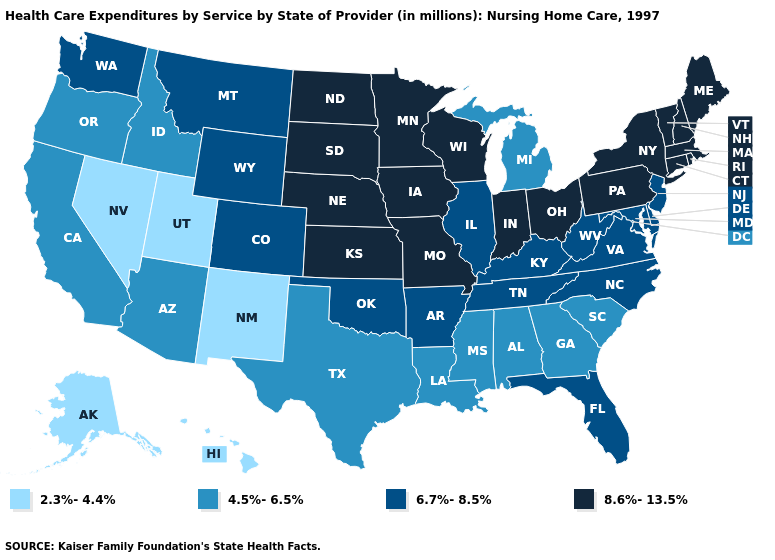Among the states that border New York , which have the lowest value?
Write a very short answer. New Jersey. Does Louisiana have a higher value than Nevada?
Quick response, please. Yes. What is the highest value in the USA?
Give a very brief answer. 8.6%-13.5%. Among the states that border Texas , does Arkansas have the highest value?
Concise answer only. Yes. What is the highest value in the USA?
Quick response, please. 8.6%-13.5%. What is the lowest value in states that border New York?
Write a very short answer. 6.7%-8.5%. How many symbols are there in the legend?
Write a very short answer. 4. Does Massachusetts have the lowest value in the USA?
Be succinct. No. How many symbols are there in the legend?
Give a very brief answer. 4. Name the states that have a value in the range 2.3%-4.4%?
Answer briefly. Alaska, Hawaii, Nevada, New Mexico, Utah. What is the value of Wisconsin?
Keep it brief. 8.6%-13.5%. Does the first symbol in the legend represent the smallest category?
Quick response, please. Yes. Name the states that have a value in the range 6.7%-8.5%?
Be succinct. Arkansas, Colorado, Delaware, Florida, Illinois, Kentucky, Maryland, Montana, New Jersey, North Carolina, Oklahoma, Tennessee, Virginia, Washington, West Virginia, Wyoming. Among the states that border New York , which have the highest value?
Answer briefly. Connecticut, Massachusetts, Pennsylvania, Vermont. 